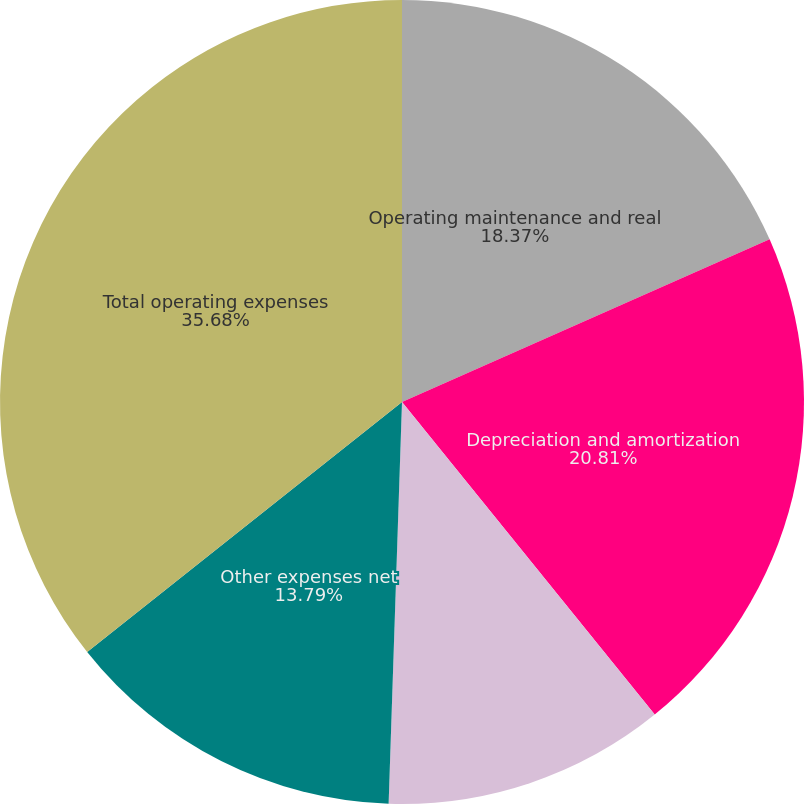Convert chart to OTSL. <chart><loc_0><loc_0><loc_500><loc_500><pie_chart><fcel>Operating maintenance and real<fcel>Depreciation and amortization<fcel>General and administrative<fcel>Other expenses net<fcel>Total operating expenses<nl><fcel>18.37%<fcel>20.81%<fcel>11.35%<fcel>13.79%<fcel>35.68%<nl></chart> 